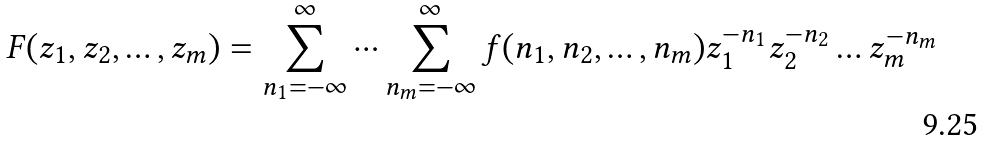<formula> <loc_0><loc_0><loc_500><loc_500>F ( z _ { 1 } , z _ { 2 } , \dots , z _ { m } ) = \sum _ { n _ { 1 } = - \infty } ^ { \infty } \cdots \sum _ { n _ { m } = - \infty } ^ { \infty } f ( n _ { 1 } , n _ { 2 } , \dots , n _ { m } ) z _ { 1 } ^ { - n _ { 1 } } z _ { 2 } ^ { - n _ { 2 } } \dots z _ { m } ^ { - n _ { m } }</formula> 